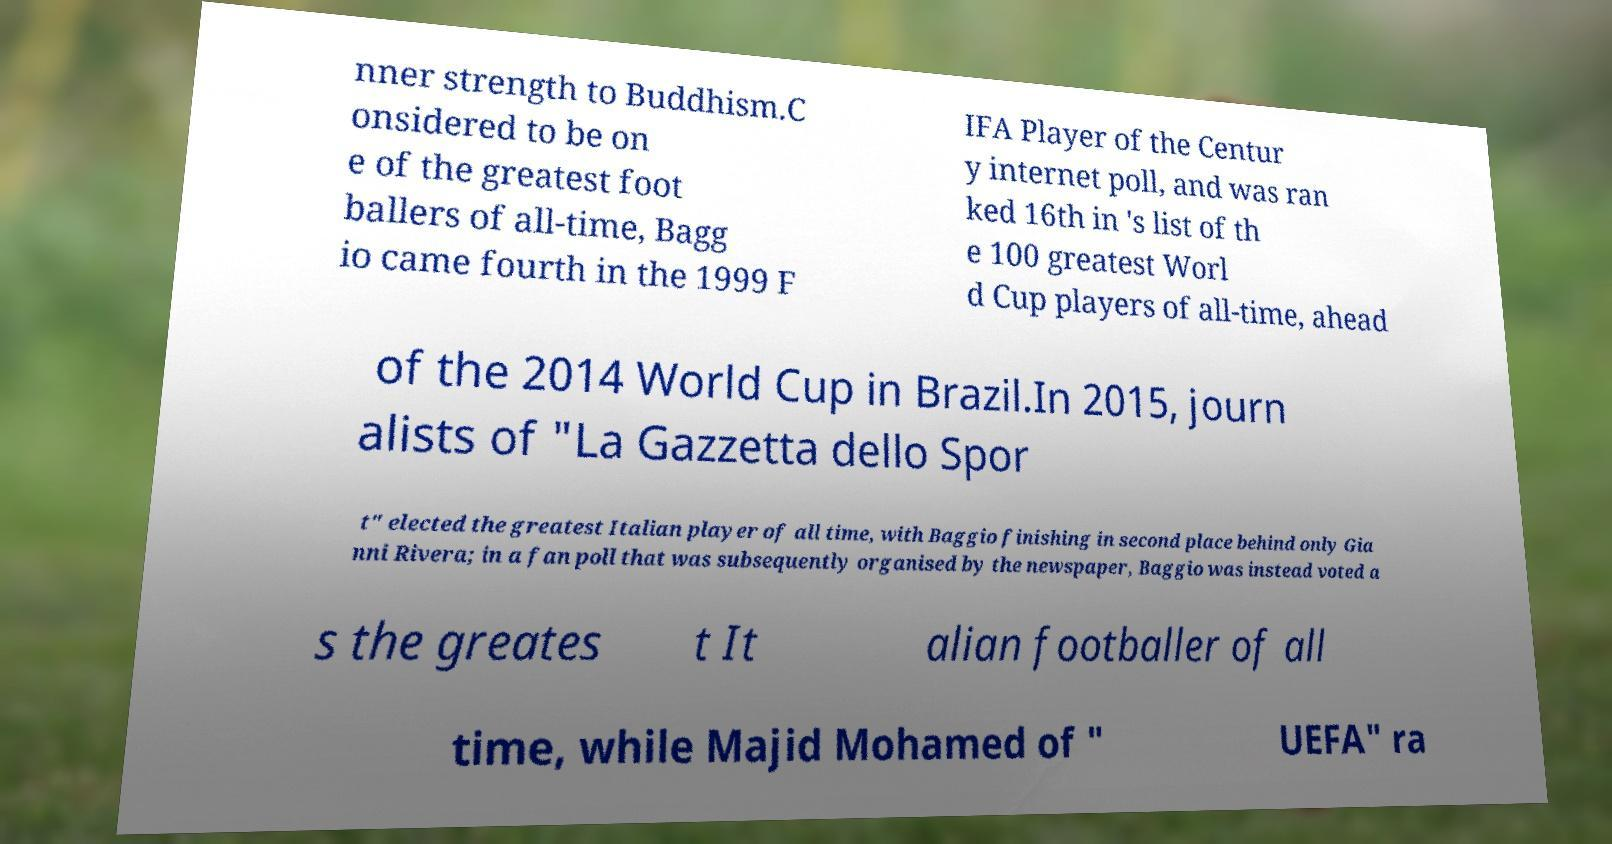I need the written content from this picture converted into text. Can you do that? nner strength to Buddhism.C onsidered to be on e of the greatest foot ballers of all-time, Bagg io came fourth in the 1999 F IFA Player of the Centur y internet poll, and was ran ked 16th in 's list of th e 100 greatest Worl d Cup players of all-time, ahead of the 2014 World Cup in Brazil.In 2015, journ alists of "La Gazzetta dello Spor t" elected the greatest Italian player of all time, with Baggio finishing in second place behind only Gia nni Rivera; in a fan poll that was subsequently organised by the newspaper, Baggio was instead voted a s the greates t It alian footballer of all time, while Majid Mohamed of " UEFA" ra 